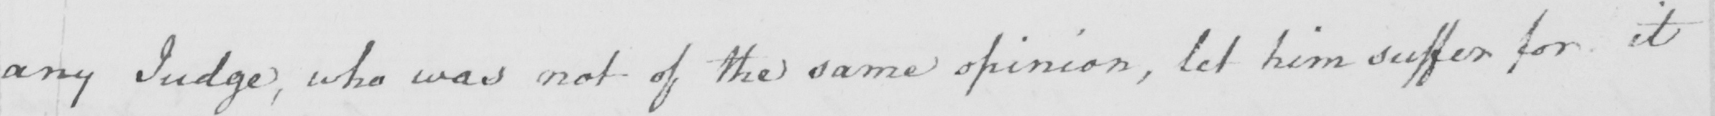Can you read and transcribe this handwriting? any Judge , who was not of the same opinion , let him suffer for it 